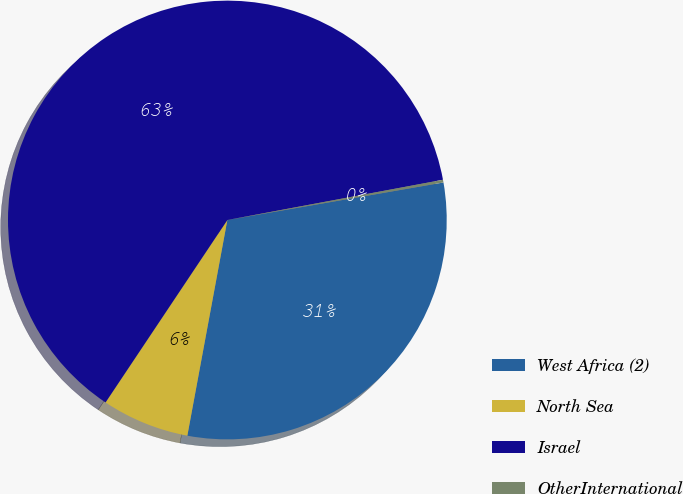Convert chart to OTSL. <chart><loc_0><loc_0><loc_500><loc_500><pie_chart><fcel>West Africa (2)<fcel>North Sea<fcel>Israel<fcel>OtherInternational<nl><fcel>30.66%<fcel>6.45%<fcel>62.7%<fcel>0.2%<nl></chart> 